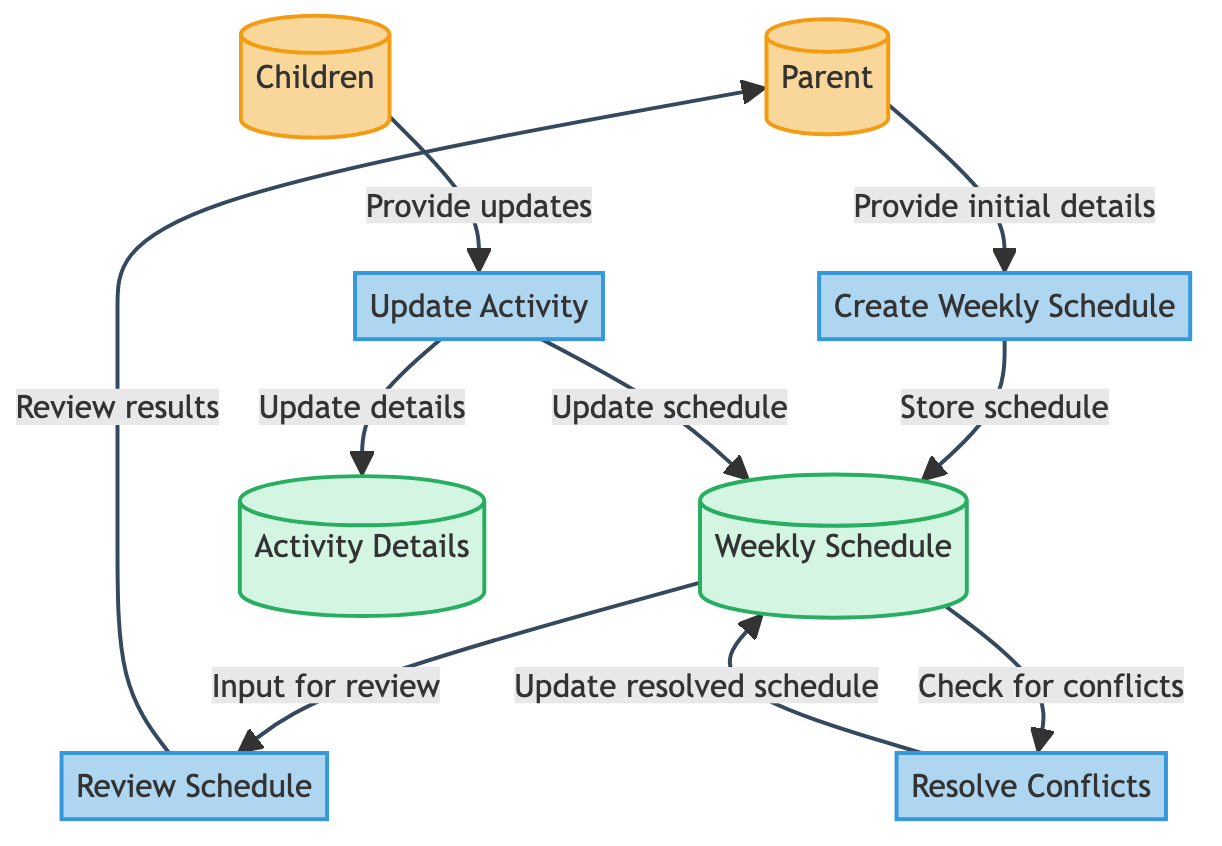What is the input for the "Create Weekly Schedule" process? The input for the "Create Weekly Schedule" process comes from the Parent, who provides initial details about the weekly activities.
Answer: Parent How many processes are defined in the diagram? The diagram lists four distinct processes: "Create Weekly Schedule," "Update Activity," "Review Schedule," and "Resolve Conflicts."
Answer: 4 Which data store is updated when children provide updates? When children provide updates, the "Weekly Schedule" store is updated to reflect the changes.
Answer: Weekly Schedule What action does the "Resolve Conflicts" process perform on the "Weekly Schedule"? The "Resolve Conflicts" process updates the "Weekly Schedule" to resolve any identified scheduling conflicts.
Answer: Update resolved schedule Who receives the results of the "Review Schedule" process? The results of the "Review Schedule" process are communicated to the Parent for further actions if needed.
Answer: Parent Which process uses the "Activity Details" data store? The "Update Activity" process uses the "Activity Details" data store to store the details of updated activities for reference.
Answer: Update Activity What flow goes from "Weekly Schedule" to "Review Schedule"? The flow from "Weekly Schedule" to "Review Schedule" is input, meaning the weekly schedule is reviewed to ensure correctness and completeness.
Answer: Input for review How many external entities are involved in the diagram? The diagram includes two external entities: the Parent and the Children.
Answer: 2 What is the type of data flow from "Update Activity" to "Activity Details"? The type of data flow from "Update Activity" to "Activity Details" is categorized as an update, indicating that the details of activities are being stored or refreshed.
Answer: Update 